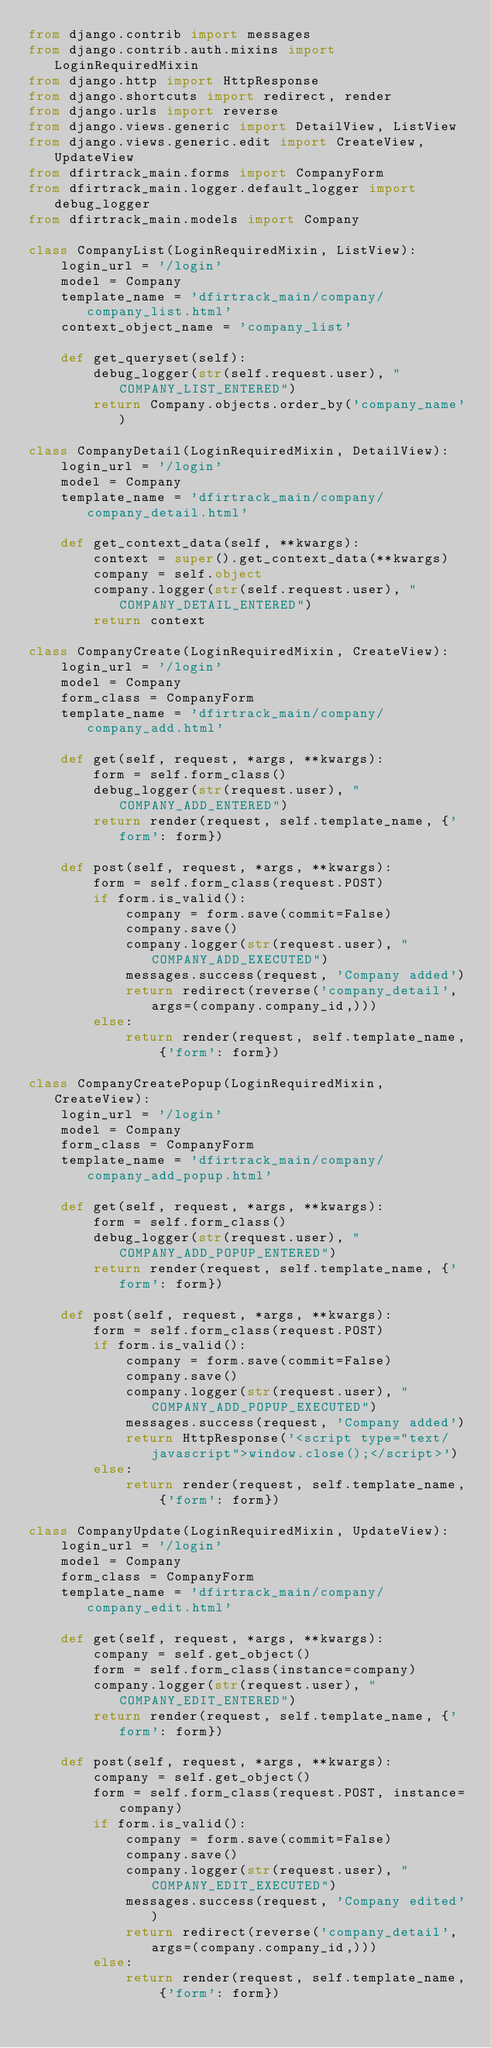Convert code to text. <code><loc_0><loc_0><loc_500><loc_500><_Python_>from django.contrib import messages
from django.contrib.auth.mixins import LoginRequiredMixin
from django.http import HttpResponse
from django.shortcuts import redirect, render
from django.urls import reverse
from django.views.generic import DetailView, ListView
from django.views.generic.edit import CreateView, UpdateView
from dfirtrack_main.forms import CompanyForm
from dfirtrack_main.logger.default_logger import debug_logger
from dfirtrack_main.models import Company

class CompanyList(LoginRequiredMixin, ListView):
    login_url = '/login'
    model = Company
    template_name = 'dfirtrack_main/company/company_list.html'
    context_object_name = 'company_list'

    def get_queryset(self):
        debug_logger(str(self.request.user), " COMPANY_LIST_ENTERED")
        return Company.objects.order_by('company_name')

class CompanyDetail(LoginRequiredMixin, DetailView):
    login_url = '/login'
    model = Company
    template_name = 'dfirtrack_main/company/company_detail.html'

    def get_context_data(self, **kwargs):
        context = super().get_context_data(**kwargs)
        company = self.object
        company.logger(str(self.request.user), " COMPANY_DETAIL_ENTERED")
        return context

class CompanyCreate(LoginRequiredMixin, CreateView):
    login_url = '/login'
    model = Company
    form_class = CompanyForm
    template_name = 'dfirtrack_main/company/company_add.html'

    def get(self, request, *args, **kwargs):
        form = self.form_class()
        debug_logger(str(request.user), " COMPANY_ADD_ENTERED")
        return render(request, self.template_name, {'form': form})

    def post(self, request, *args, **kwargs):
        form = self.form_class(request.POST)
        if form.is_valid():
            company = form.save(commit=False)
            company.save()
            company.logger(str(request.user), " COMPANY_ADD_EXECUTED")
            messages.success(request, 'Company added')
            return redirect(reverse('company_detail', args=(company.company_id,)))
        else:
            return render(request, self.template_name, {'form': form})

class CompanyCreatePopup(LoginRequiredMixin, CreateView):
    login_url = '/login'
    model = Company
    form_class = CompanyForm
    template_name = 'dfirtrack_main/company/company_add_popup.html'

    def get(self, request, *args, **kwargs):
        form = self.form_class()
        debug_logger(str(request.user), " COMPANY_ADD_POPUP_ENTERED")
        return render(request, self.template_name, {'form': form})

    def post(self, request, *args, **kwargs):
        form = self.form_class(request.POST)
        if form.is_valid():
            company = form.save(commit=False)
            company.save()
            company.logger(str(request.user), " COMPANY_ADD_POPUP_EXECUTED")
            messages.success(request, 'Company added')
            return HttpResponse('<script type="text/javascript">window.close();</script>')
        else:
            return render(request, self.template_name, {'form': form})

class CompanyUpdate(LoginRequiredMixin, UpdateView):
    login_url = '/login'
    model = Company
    form_class = CompanyForm
    template_name = 'dfirtrack_main/company/company_edit.html'

    def get(self, request, *args, **kwargs):
        company = self.get_object()
        form = self.form_class(instance=company)
        company.logger(str(request.user), " COMPANY_EDIT_ENTERED")
        return render(request, self.template_name, {'form': form})

    def post(self, request, *args, **kwargs):
        company = self.get_object()
        form = self.form_class(request.POST, instance=company)
        if form.is_valid():
            company = form.save(commit=False)
            company.save()
            company.logger(str(request.user), " COMPANY_EDIT_EXECUTED")
            messages.success(request, 'Company edited')
            return redirect(reverse('company_detail', args=(company.company_id,)))
        else:
            return render(request, self.template_name, {'form': form})
</code> 